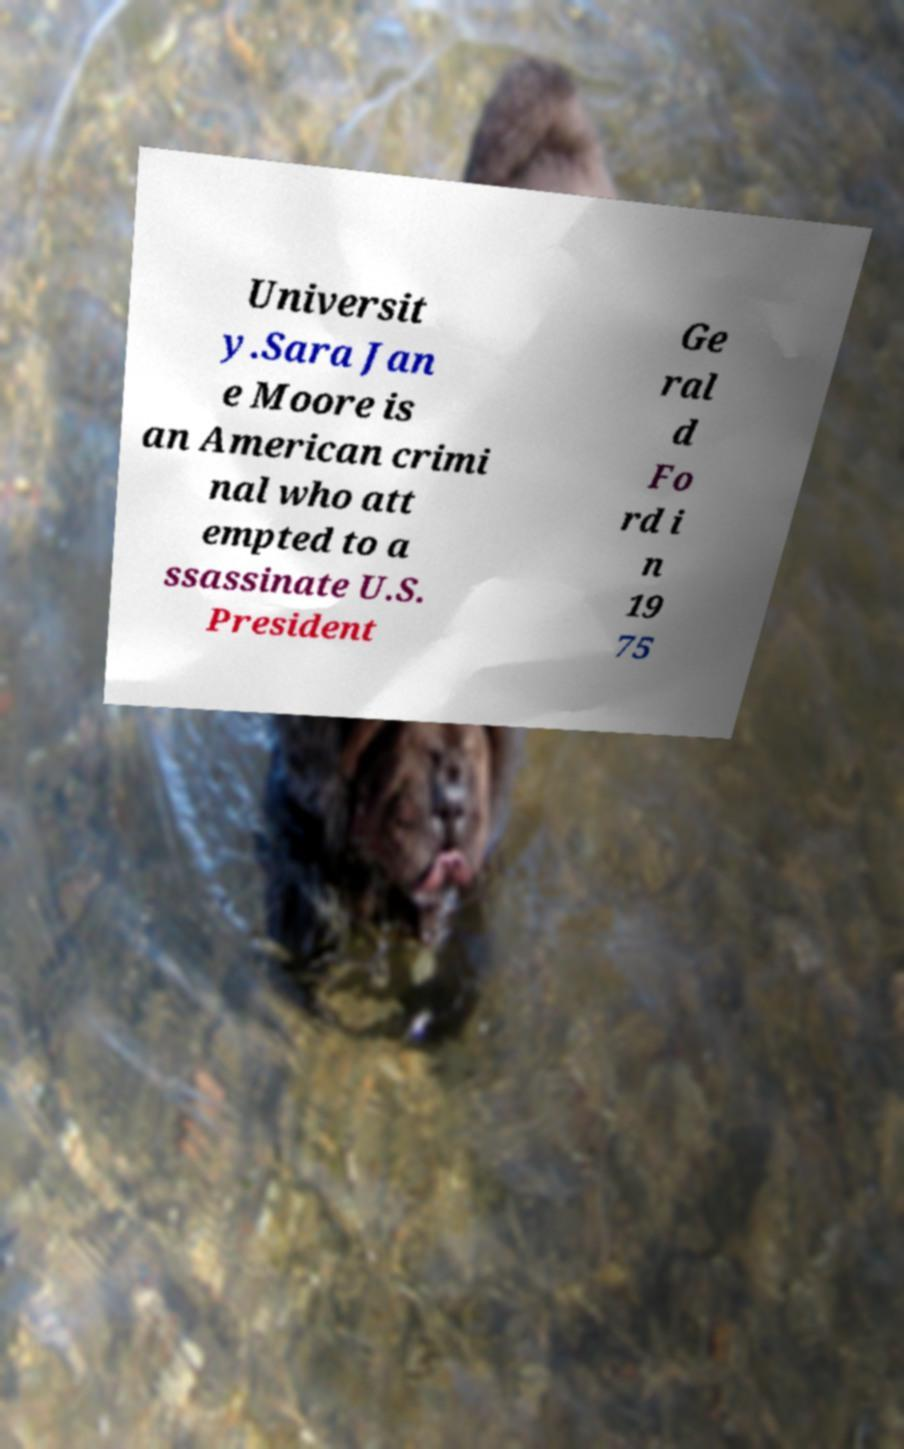Can you read and provide the text displayed in the image?This photo seems to have some interesting text. Can you extract and type it out for me? Universit y.Sara Jan e Moore is an American crimi nal who att empted to a ssassinate U.S. President Ge ral d Fo rd i n 19 75 